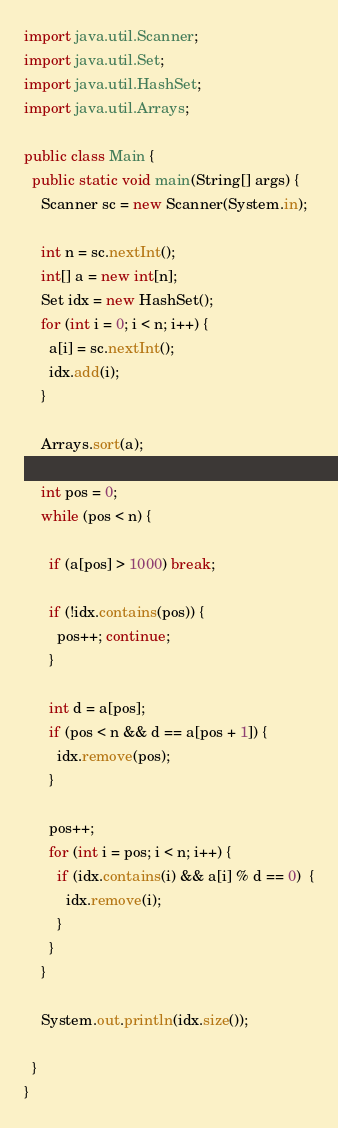<code> <loc_0><loc_0><loc_500><loc_500><_Java_>import java.util.Scanner;
import java.util.Set;
import java.util.HashSet;
import java.util.Arrays;

public class Main {
  public static void main(String[] args) {
    Scanner sc = new Scanner(System.in);

    int n = sc.nextInt();
    int[] a = new int[n];
    Set idx = new HashSet();
    for (int i = 0; i < n; i++) {
      a[i] = sc.nextInt();
      idx.add(i);
    }

    Arrays.sort(a);

    int pos = 0;
    while (pos < n) {

      if (a[pos] > 1000) break;

      if (!idx.contains(pos)) {
        pos++; continue;
      }

      int d = a[pos];
      if (pos < n && d == a[pos + 1]) {
        idx.remove(pos);
      }

      pos++;
      for (int i = pos; i < n; i++) {
        if (idx.contains(i) && a[i] % d == 0)  {
          idx.remove(i);
        }
      }
    }

    System.out.println(idx.size());

  }
}
</code> 